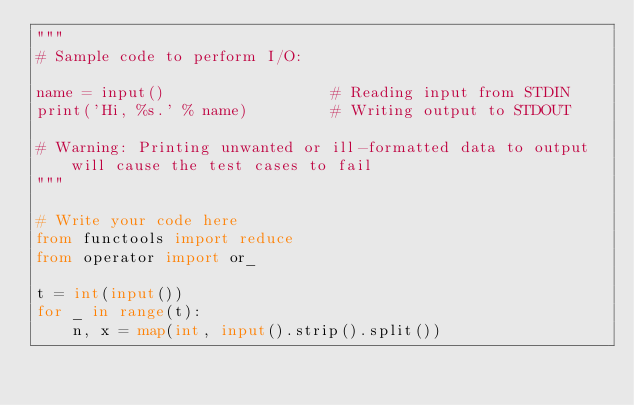Convert code to text. <code><loc_0><loc_0><loc_500><loc_500><_Python_>"""
# Sample code to perform I/O:

name = input()                  # Reading input from STDIN
print('Hi, %s.' % name)         # Writing output to STDOUT

# Warning: Printing unwanted or ill-formatted data to output will cause the test cases to fail
"""

# Write your code here
from functools import reduce
from operator import or_

t = int(input())
for _ in range(t):
    n, x = map(int, input().strip().split())</code> 